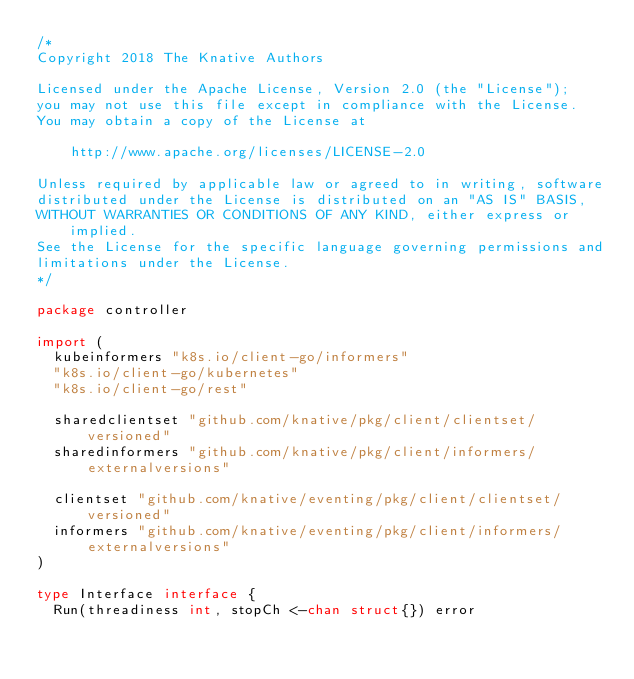<code> <loc_0><loc_0><loc_500><loc_500><_Go_>/*
Copyright 2018 The Knative Authors

Licensed under the Apache License, Version 2.0 (the "License");
you may not use this file except in compliance with the License.
You may obtain a copy of the License at

    http://www.apache.org/licenses/LICENSE-2.0

Unless required by applicable law or agreed to in writing, software
distributed under the License is distributed on an "AS IS" BASIS,
WITHOUT WARRANTIES OR CONDITIONS OF ANY KIND, either express or implied.
See the License for the specific language governing permissions and
limitations under the License.
*/

package controller

import (
	kubeinformers "k8s.io/client-go/informers"
	"k8s.io/client-go/kubernetes"
	"k8s.io/client-go/rest"

	sharedclientset "github.com/knative/pkg/client/clientset/versioned"
	sharedinformers "github.com/knative/pkg/client/informers/externalversions"

	clientset "github.com/knative/eventing/pkg/client/clientset/versioned"
	informers "github.com/knative/eventing/pkg/client/informers/externalversions"
)

type Interface interface {
	Run(threadiness int, stopCh <-chan struct{}) error</code> 